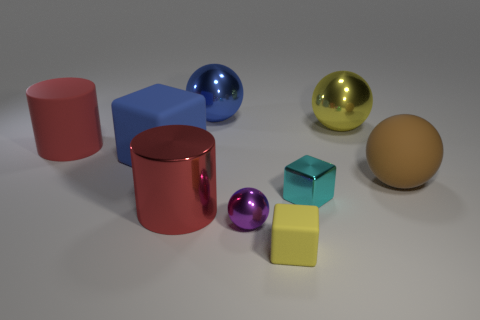Subtract all cyan blocks. Subtract all green cylinders. How many blocks are left? 2 Subtract all cubes. How many objects are left? 6 Add 9 big rubber cylinders. How many big rubber cylinders exist? 10 Subtract 0 brown cubes. How many objects are left? 9 Subtract all large purple metal cylinders. Subtract all red matte cylinders. How many objects are left? 8 Add 7 red matte cylinders. How many red matte cylinders are left? 8 